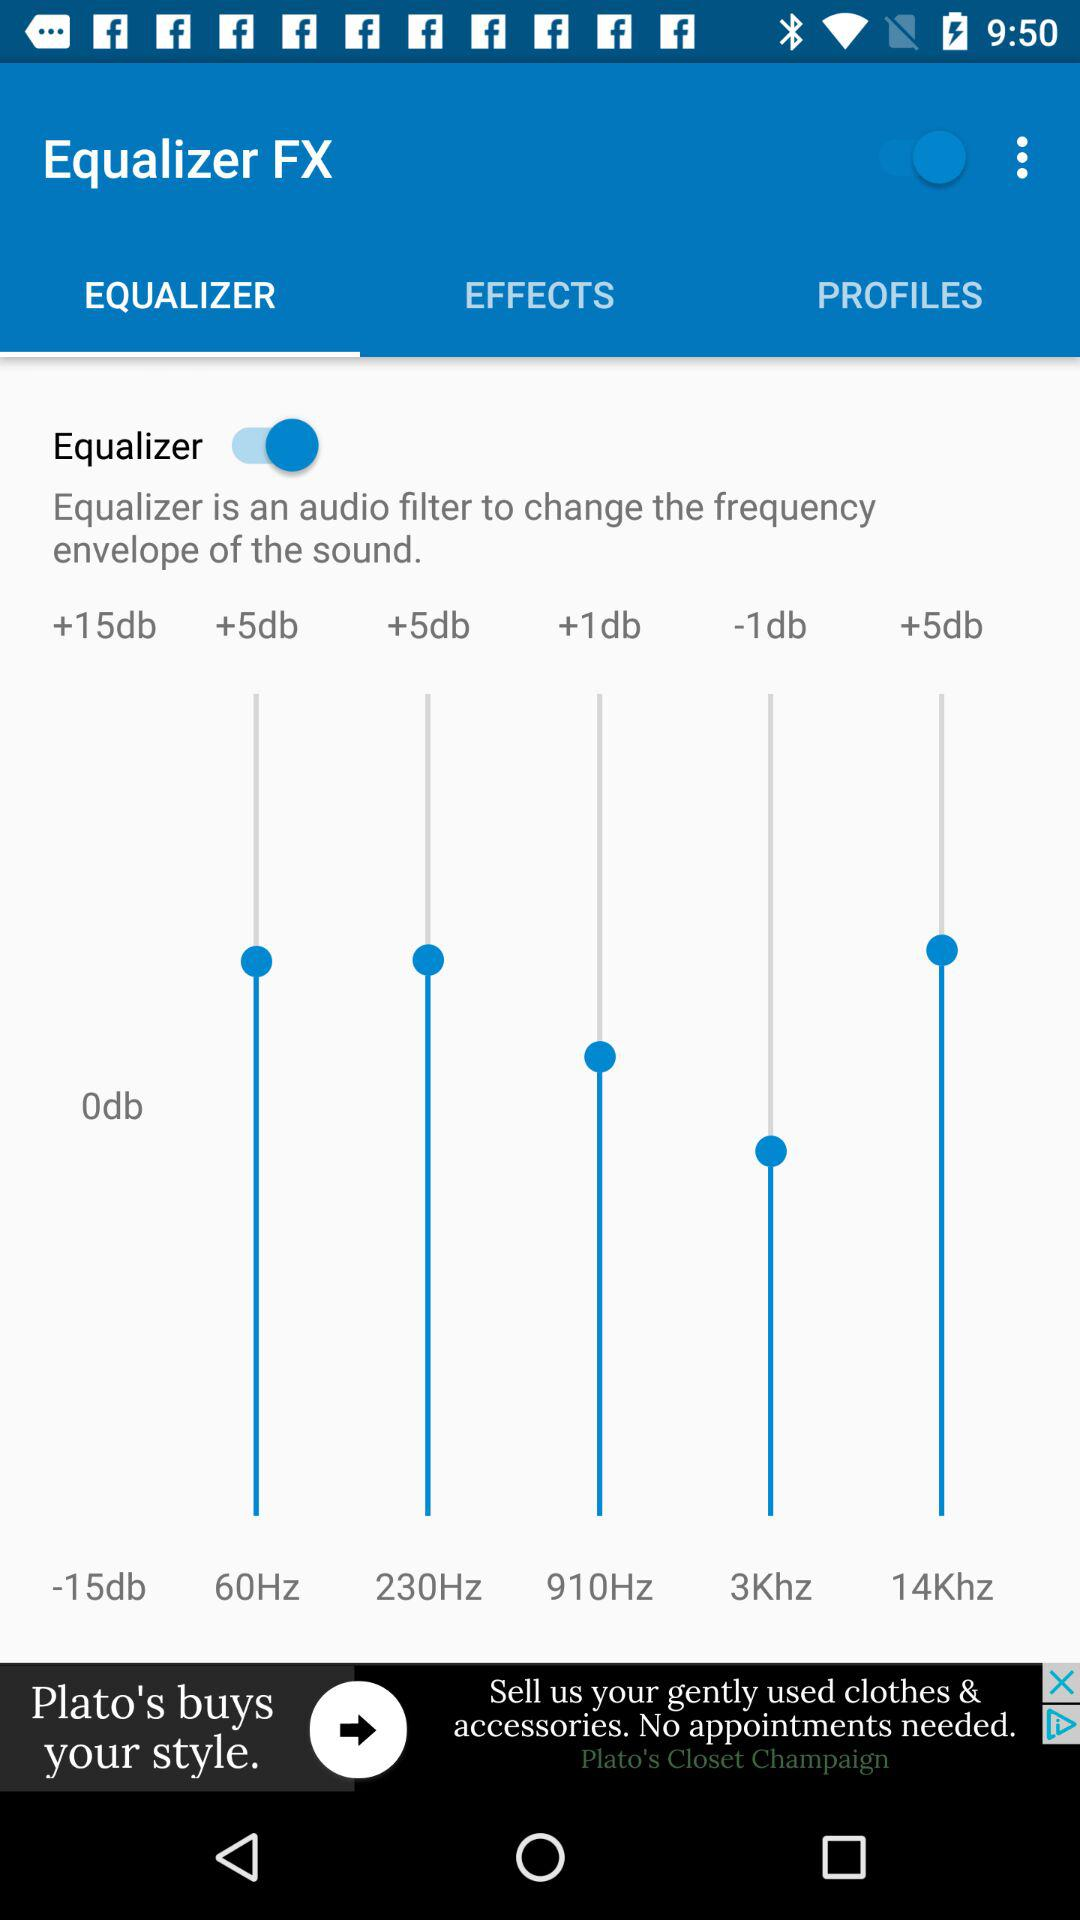Which tab is selected? The selected tab is "EQUALIZER". 